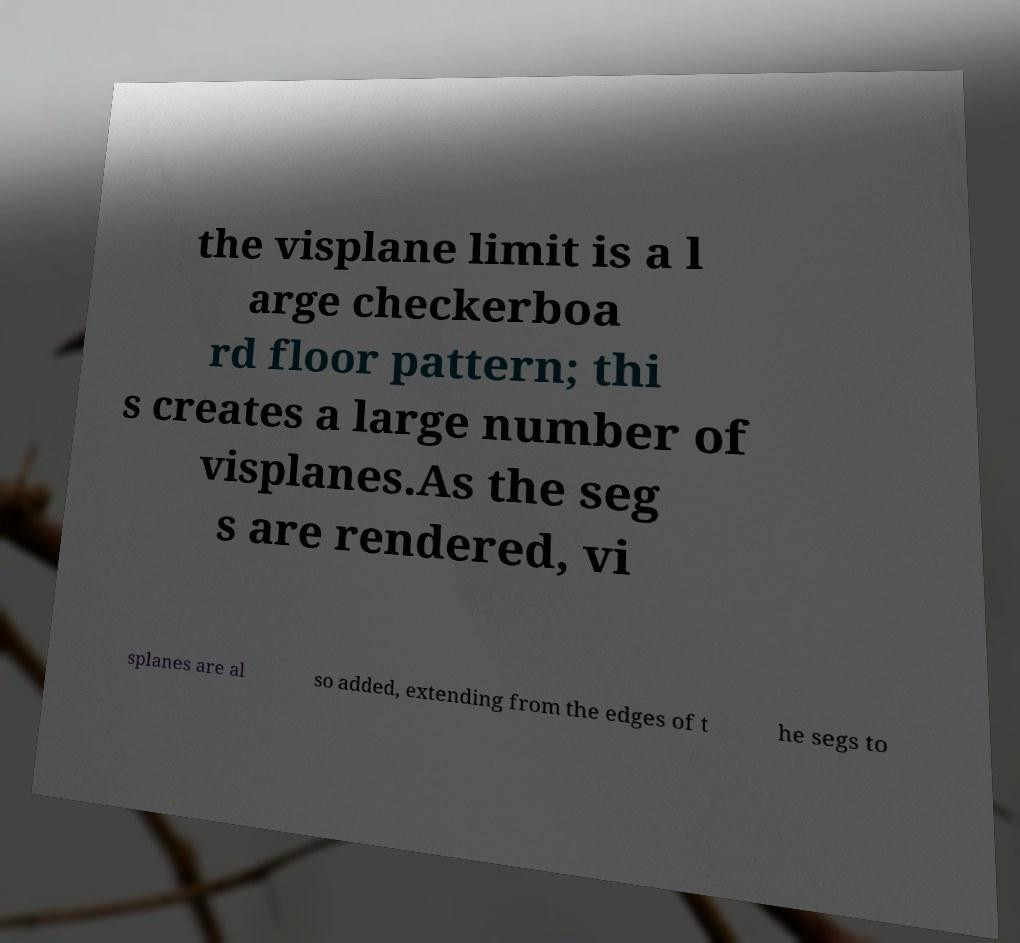For documentation purposes, I need the text within this image transcribed. Could you provide that? the visplane limit is a l arge checkerboa rd floor pattern; thi s creates a large number of visplanes.As the seg s are rendered, vi splanes are al so added, extending from the edges of t he segs to 